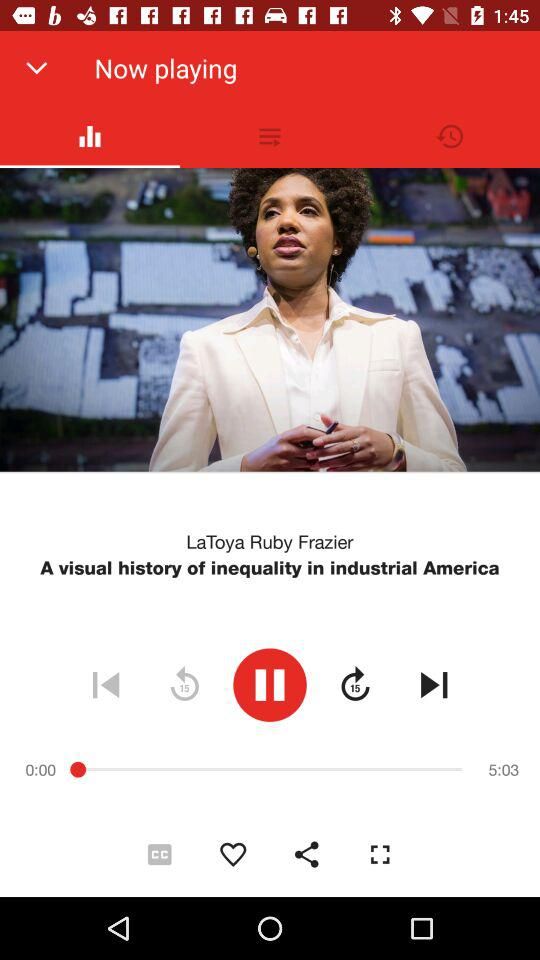What is the time duration of the video? The duration is 5 minutes and 3 seconds. 